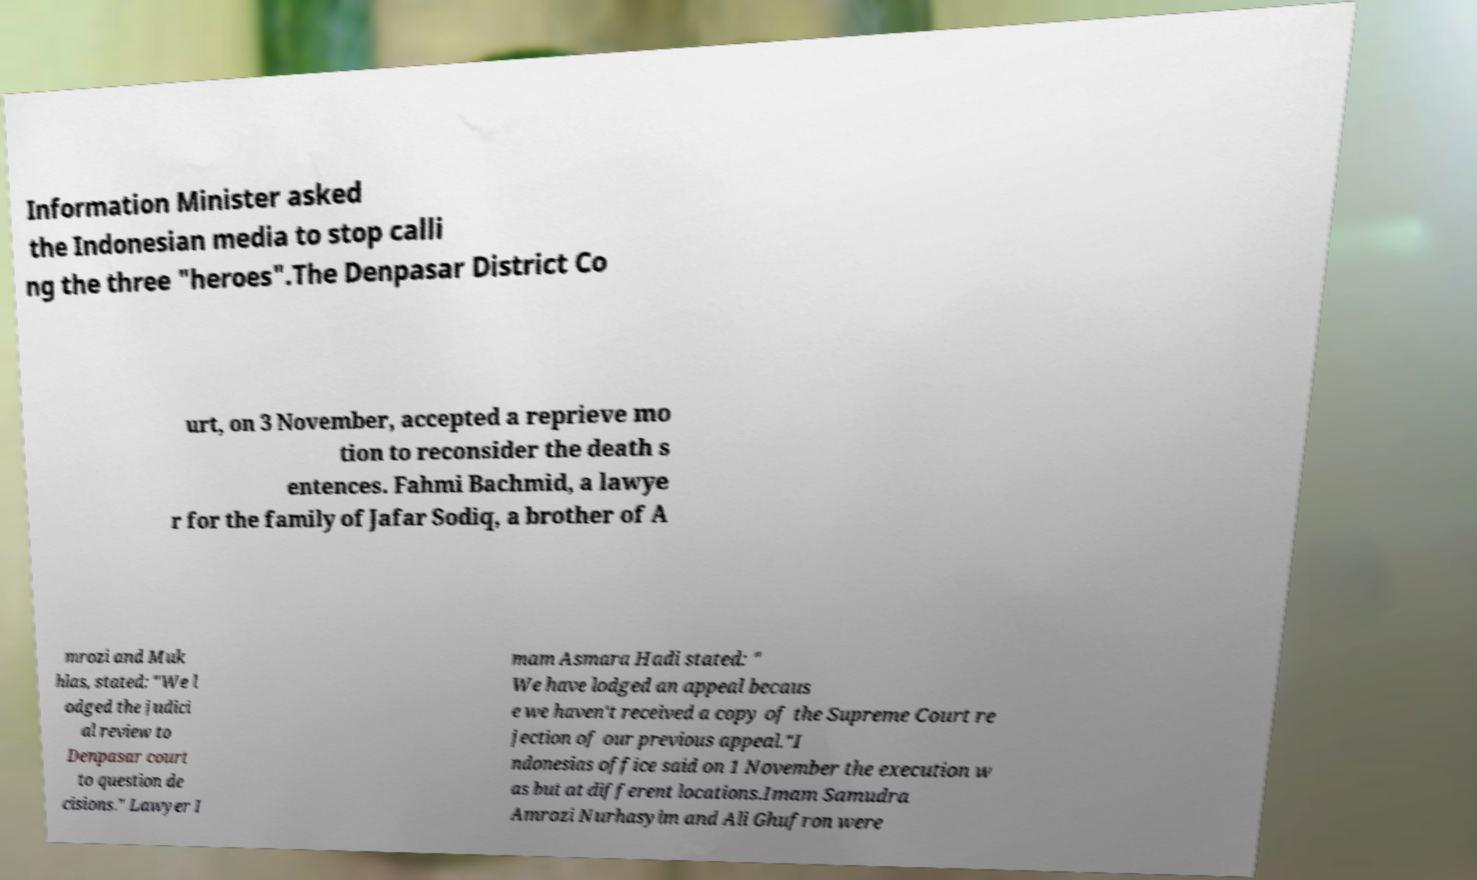There's text embedded in this image that I need extracted. Can you transcribe it verbatim? Information Minister asked the Indonesian media to stop calli ng the three "heroes".The Denpasar District Co urt, on 3 November, accepted a reprieve mo tion to reconsider the death s entences. Fahmi Bachmid, a lawye r for the family of Jafar Sodiq, a brother of A mrozi and Muk hlas, stated: "We l odged the judici al review to Denpasar court to question de cisions." Lawyer I mam Asmara Hadi stated: " We have lodged an appeal becaus e we haven't received a copy of the Supreme Court re jection of our previous appeal."I ndonesias office said on 1 November the execution w as but at different locations.Imam Samudra Amrozi Nurhasyim and Ali Ghufron were 